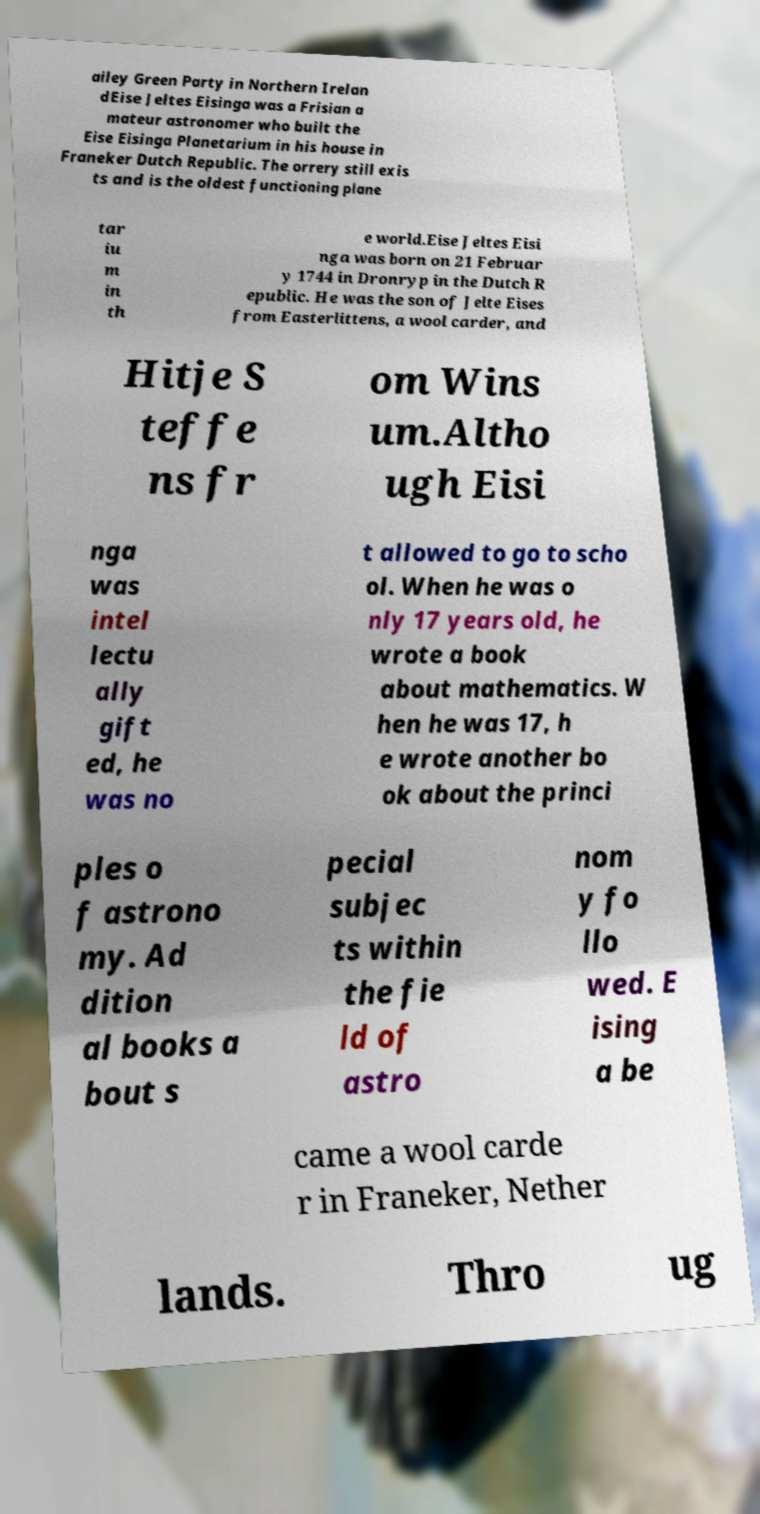Could you extract and type out the text from this image? ailey Green Party in Northern Irelan dEise Jeltes Eisinga was a Frisian a mateur astronomer who built the Eise Eisinga Planetarium in his house in Franeker Dutch Republic. The orrery still exis ts and is the oldest functioning plane tar iu m in th e world.Eise Jeltes Eisi nga was born on 21 Februar y 1744 in Dronryp in the Dutch R epublic. He was the son of Jelte Eises from Easterlittens, a wool carder, and Hitje S teffe ns fr om Wins um.Altho ugh Eisi nga was intel lectu ally gift ed, he was no t allowed to go to scho ol. When he was o nly 17 years old, he wrote a book about mathematics. W hen he was 17, h e wrote another bo ok about the princi ples o f astrono my. Ad dition al books a bout s pecial subjec ts within the fie ld of astro nom y fo llo wed. E ising a be came a wool carde r in Franeker, Nether lands. Thro ug 